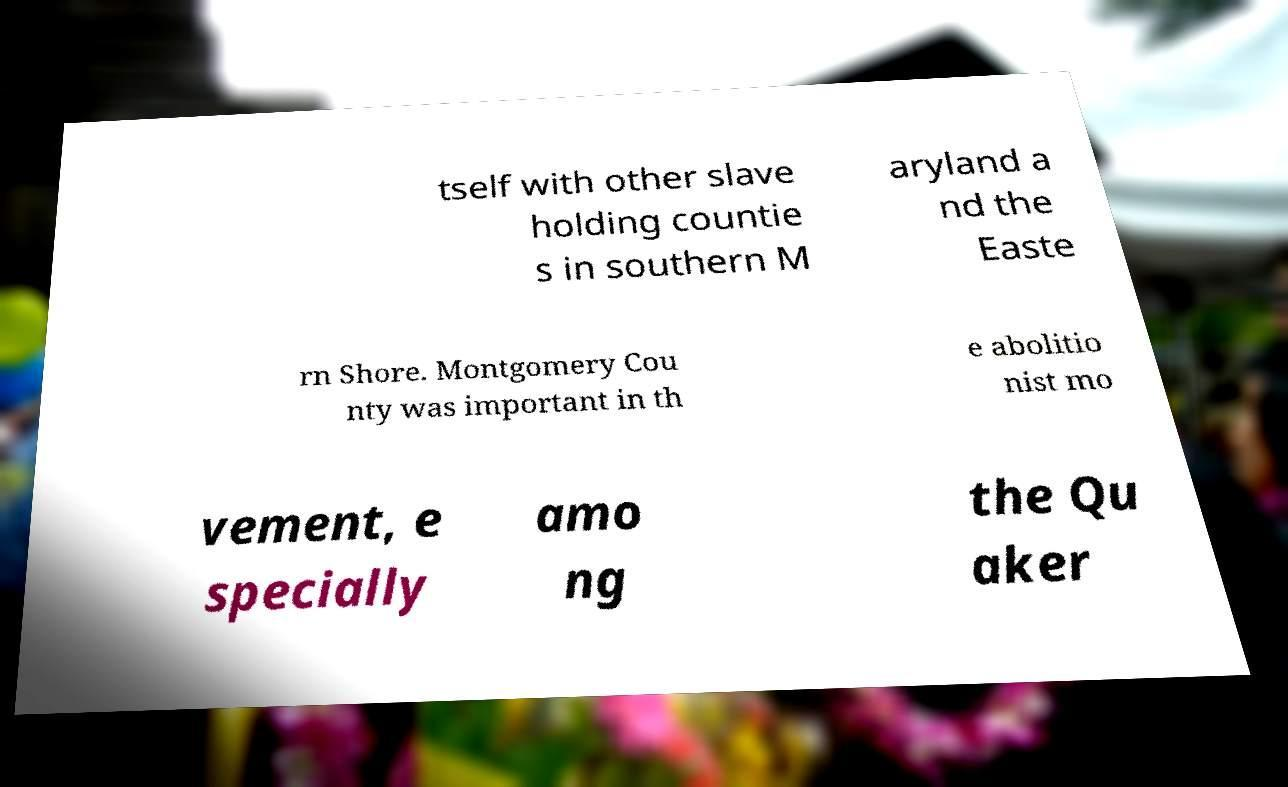Could you extract and type out the text from this image? tself with other slave holding countie s in southern M aryland a nd the Easte rn Shore. Montgomery Cou nty was important in th e abolitio nist mo vement, e specially amo ng the Qu aker 